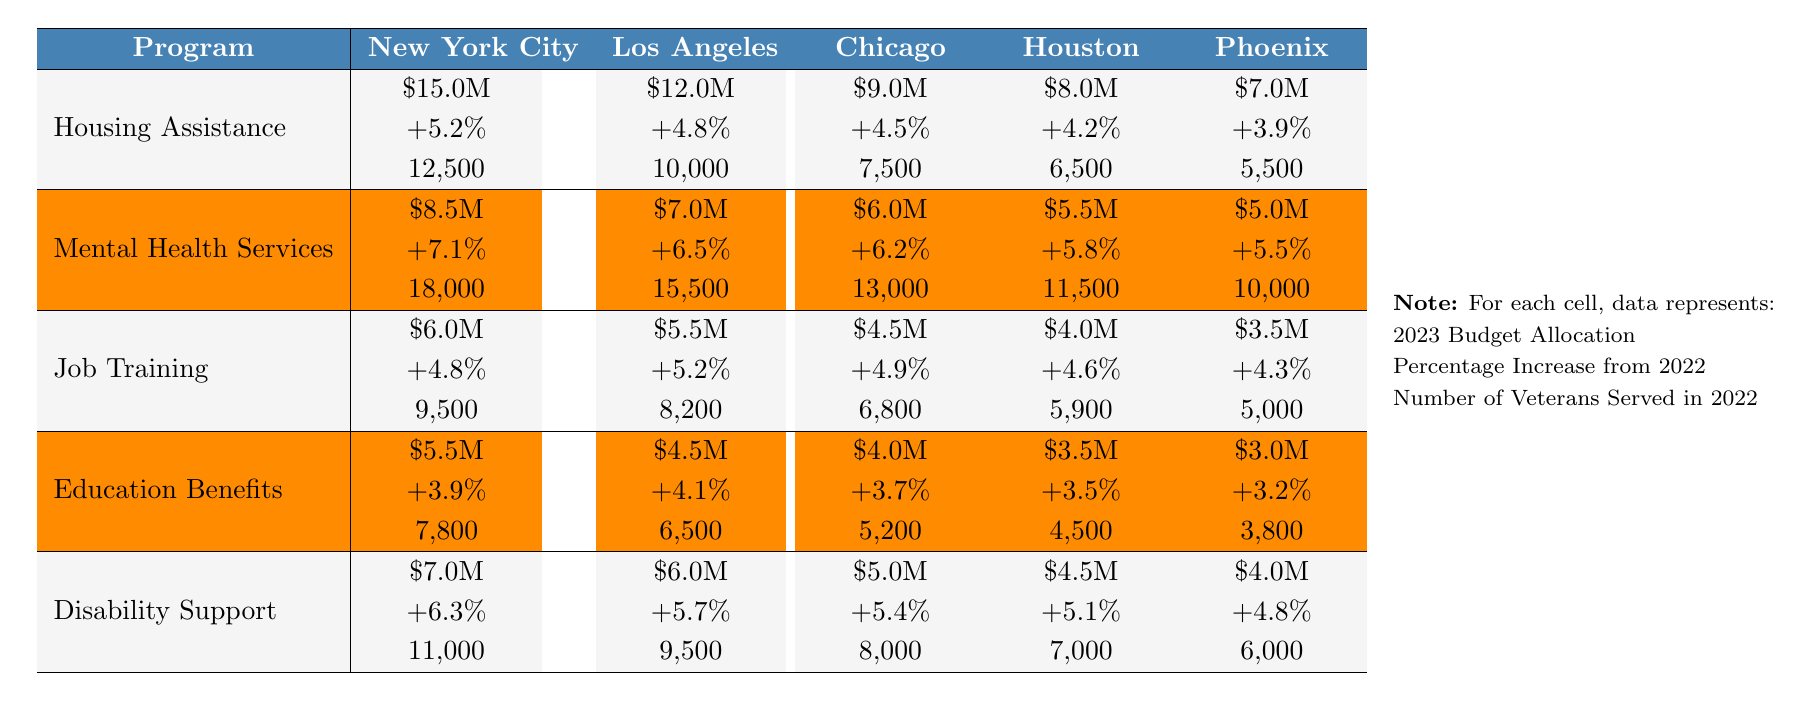What is the total budget allocation for Housing Assistance in New York City? The budget allocation for Housing Assistance in New York City is $15 million, as indicated directly in the table under the corresponding city and program.
Answer: $15 million What city has the highest budget allocation for Mental Health Services? In the table, New York City has the highest budget allocation for Mental Health Services at $8.5 million, compared to other cities listed.
Answer: New York City Which program received the lowest funding in Chicago? The lowest funding in Chicago is for Job Training, which received $4.5 million, as noted in the budget allocation row for that city.
Answer: Job Training How much did the budget for Education Benefits increase in Los Angeles from 2022 to 2023? The table shows the budget for Education Benefits in Los Angeles is $4.5 million in 2023, up by 4.1% from the previous year. To find the increase, we can calculate the previous year's budget: 4.5M / (1 + 0.041) = approximately $4.32 million, which means the increase is approximately $0.18 million.
Answer: Approximately $0.18 million What is the average budget allocation for Disability Support across all cities? To find the average, we sum the allocations: $7 million (NYC) + $6 million (LA) + $5 million (Chicago) + $4.5 million (Houston) + $4 million (Phoenix) = $32.5 million. Then, divide by 5 cities: $32.5 million / 5 = $6.5 million.
Answer: $6.5 million Which city serves the most veterans in the Job Training program? In the table, New York City serves the most veterans in Job Training, with 9,500 veterans served, more than Los Angeles (8,200) and others.
Answer: New York City Is there a program that has seen a budget increase of more than 6% in Houston? By checking the percentage increases for each program in Houston, we see that only Mental Health Services has a 5.8% increase, which is less than 6%. Therefore, the answer is no, no program saw an increase greater than 6%.
Answer: No What is the total number of veterans served across all programs in Phoenix? To find the total, we sum the veterans served in Phoenix: 5,500 (Housing Assistance) + 5,000 (Job Training) + 3,000 (Education Benefits) + 4,000 (Disability Support) + 10,000 (Mental Health Services) = 27,500 veterans.
Answer: 27,500 veterans What is the percentage increase for Job Training in Chicago? The table shows that Job Training in Chicago had a percentage increase of 4.9% from 2022 to 2023 as found in the corresponding row.
Answer: 4.9% Which two programs received the highest budget allocations in Los Angeles? The highest allocations in Los Angeles are for Housing Assistance ($12 million) and Mental Health Services ($7 million), positioning them as the two programs with the most funding in that city.
Answer: Housing Assistance and Mental Health Services 